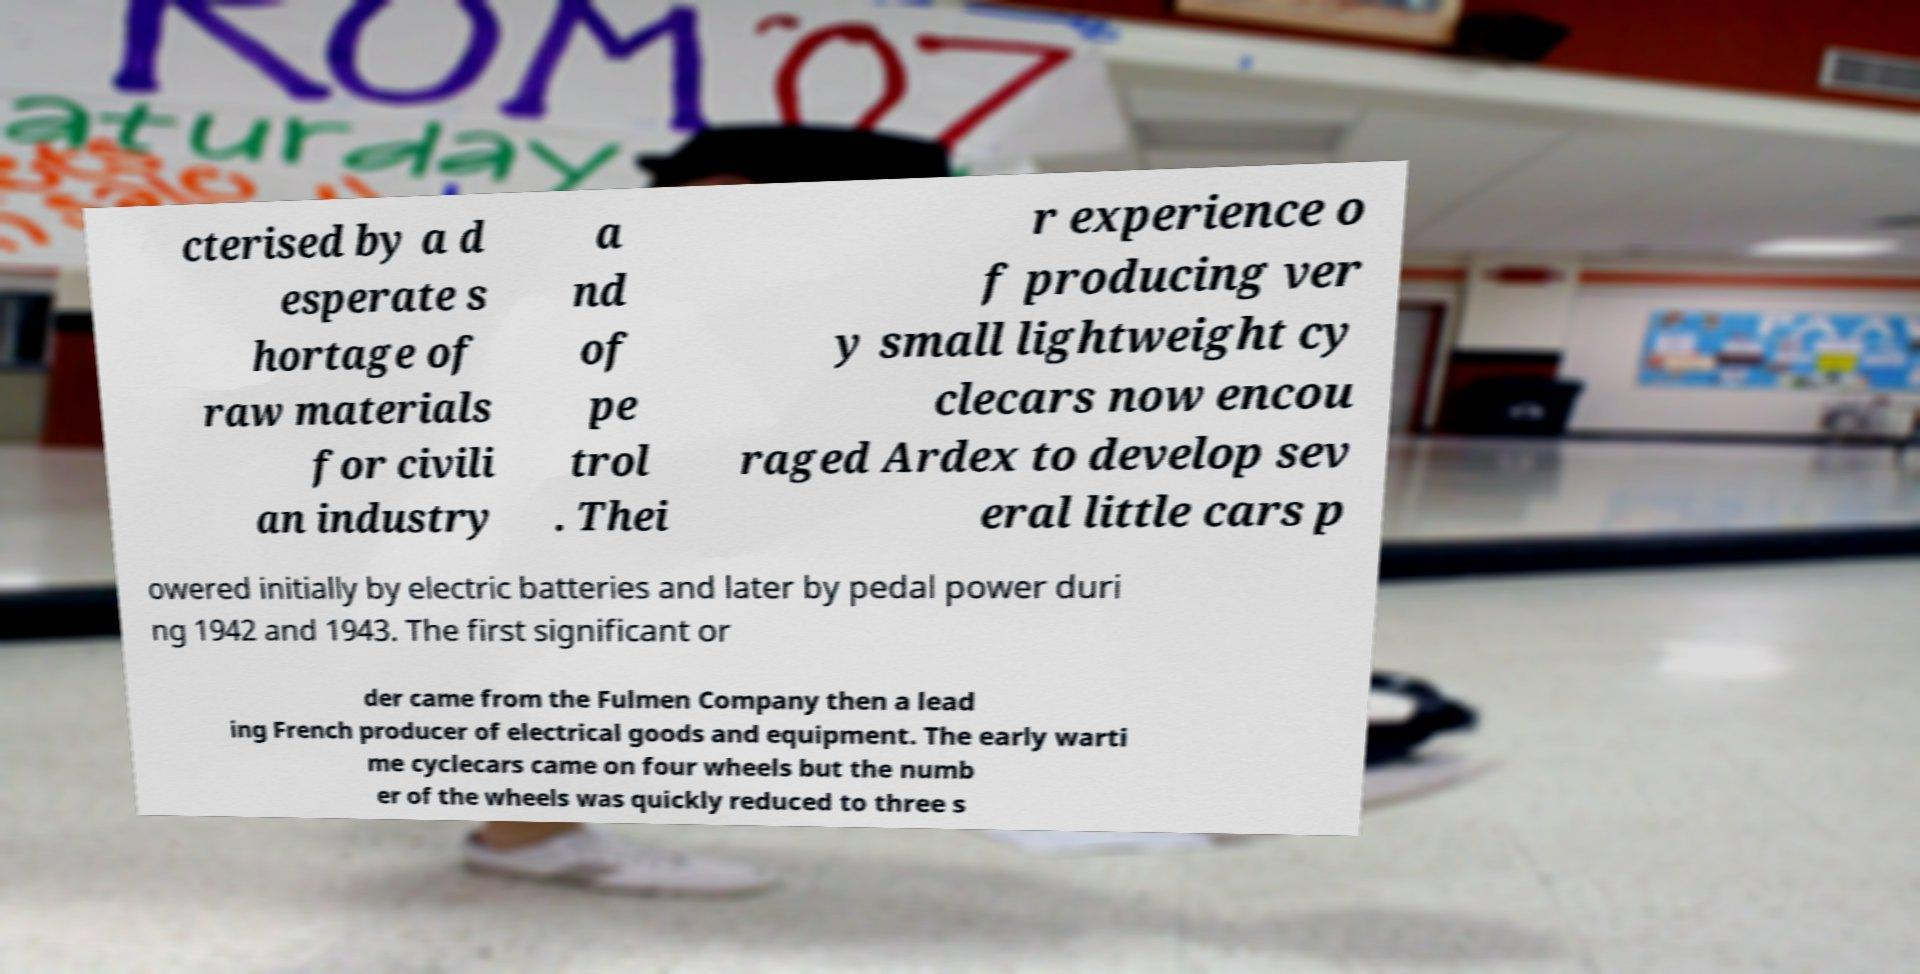There's text embedded in this image that I need extracted. Can you transcribe it verbatim? cterised by a d esperate s hortage of raw materials for civili an industry a nd of pe trol . Thei r experience o f producing ver y small lightweight cy clecars now encou raged Ardex to develop sev eral little cars p owered initially by electric batteries and later by pedal power duri ng 1942 and 1943. The first significant or der came from the Fulmen Company then a lead ing French producer of electrical goods and equipment. The early warti me cyclecars came on four wheels but the numb er of the wheels was quickly reduced to three s 